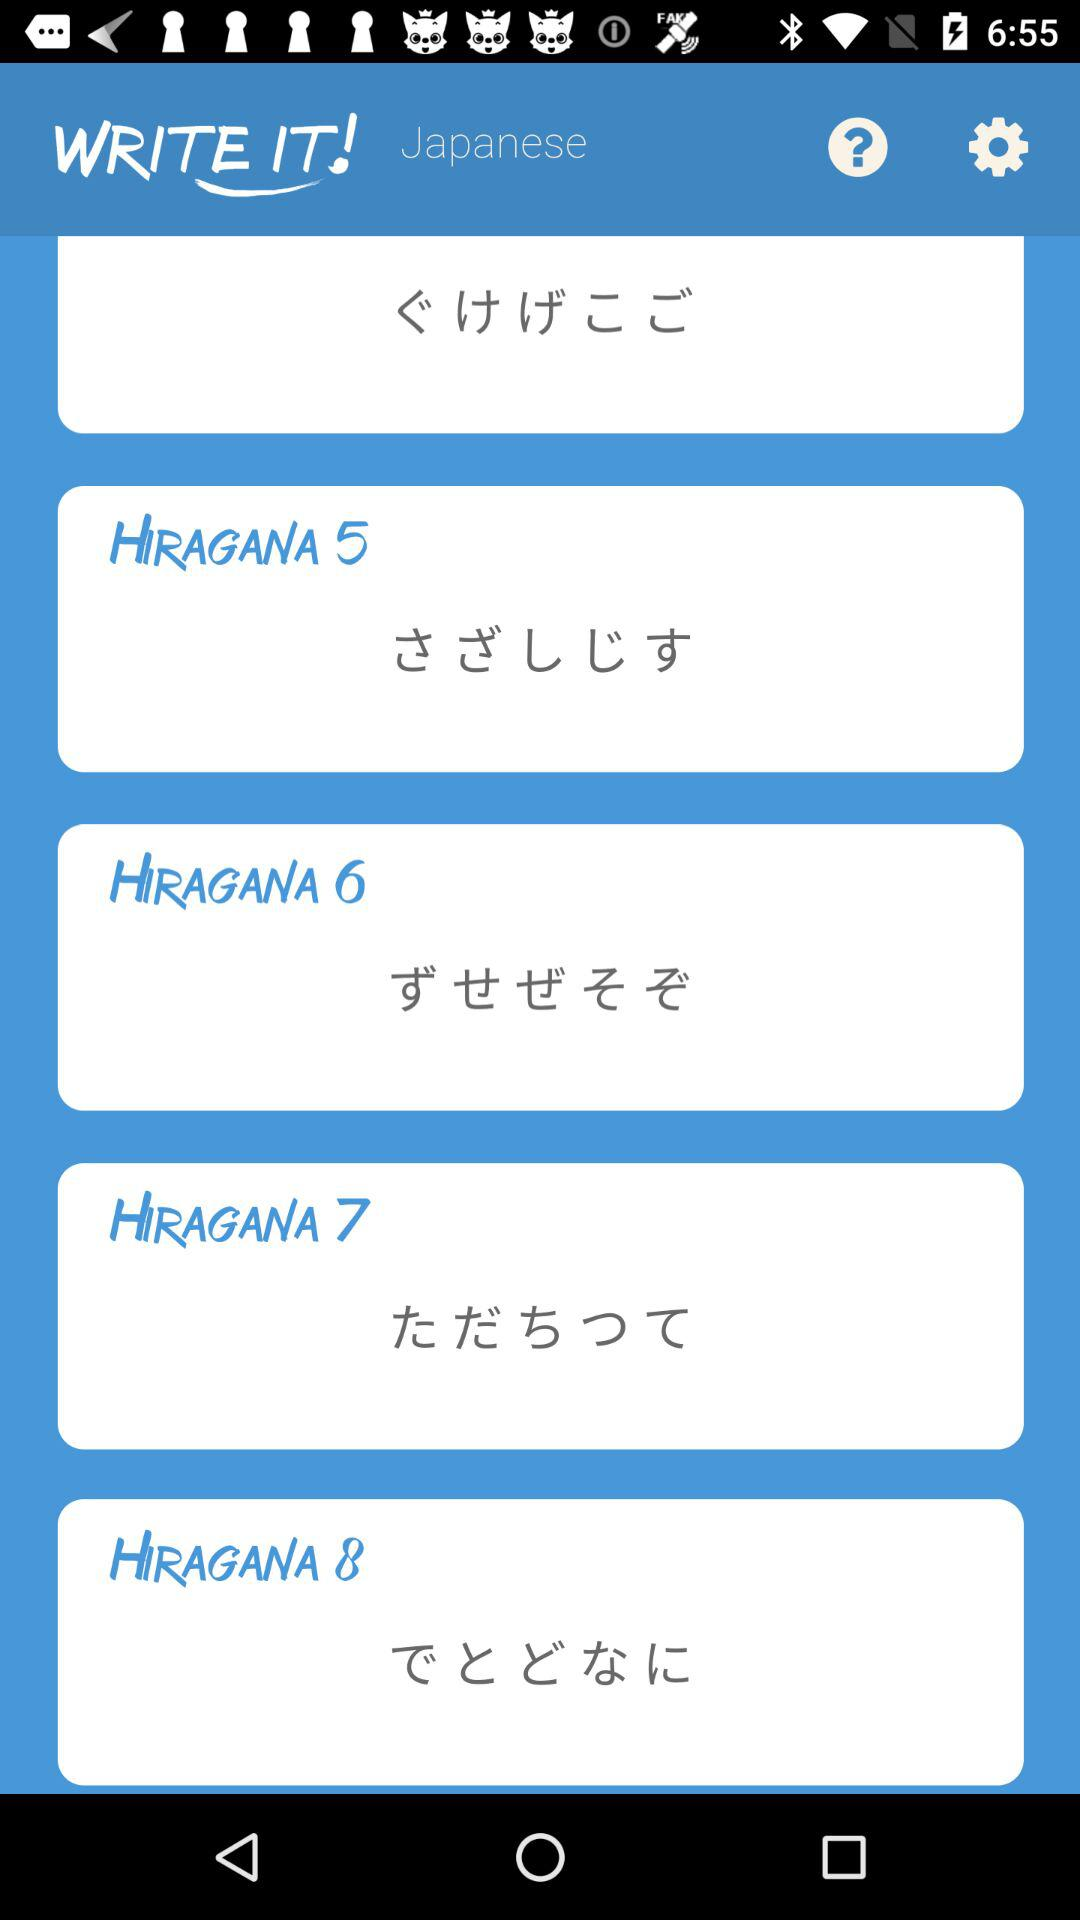How many hiragana lessons are there?
Answer the question using a single word or phrase. 8 